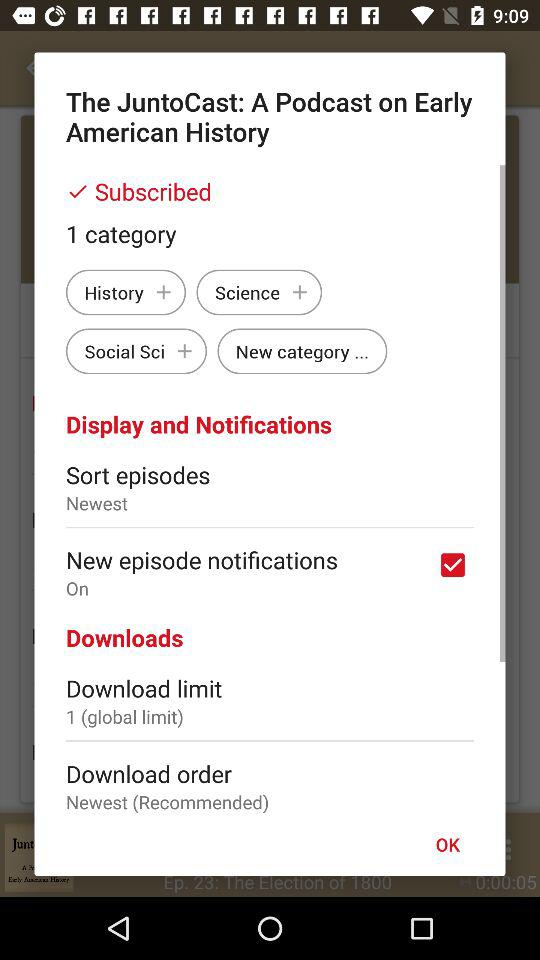What is the download limit? The download limit is 1 (global limit). 